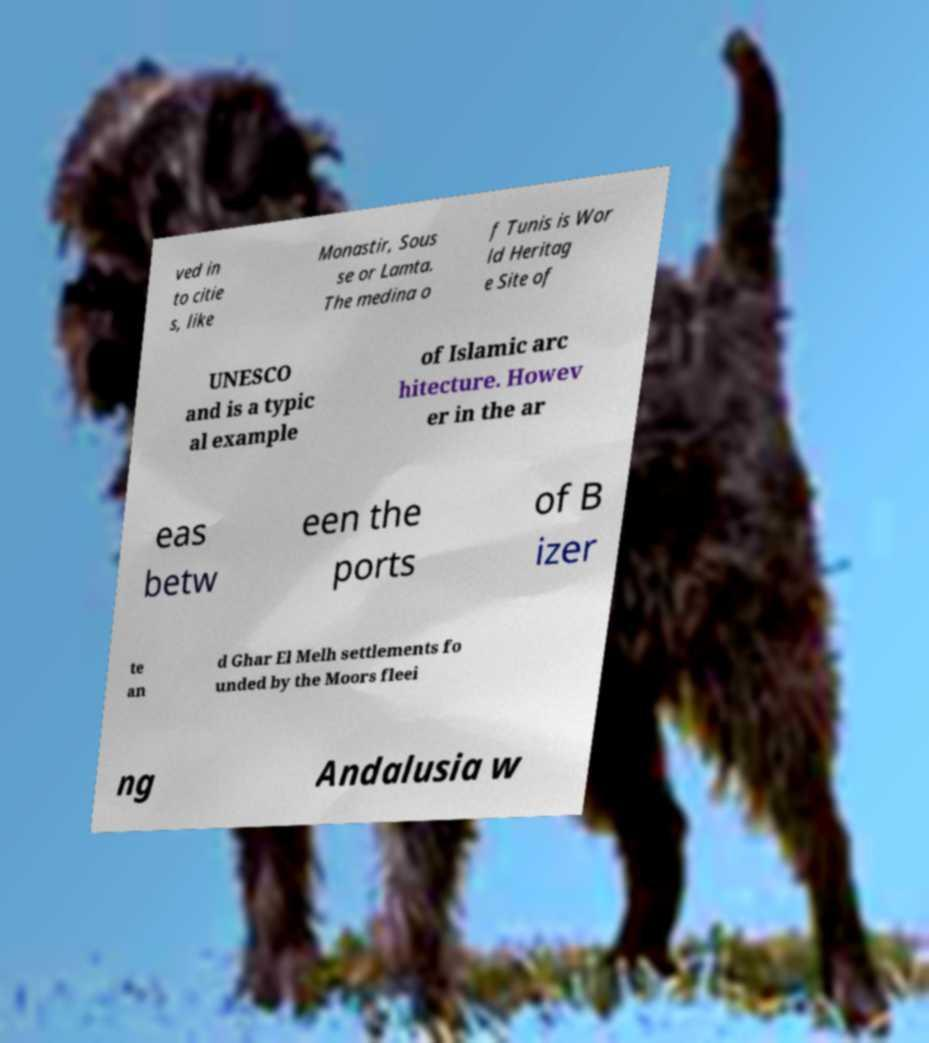For documentation purposes, I need the text within this image transcribed. Could you provide that? ved in to citie s, like Monastir, Sous se or Lamta. The medina o f Tunis is Wor ld Heritag e Site of UNESCO and is a typic al example of Islamic arc hitecture. Howev er in the ar eas betw een the ports of B izer te an d Ghar El Melh settlements fo unded by the Moors fleei ng Andalusia w 